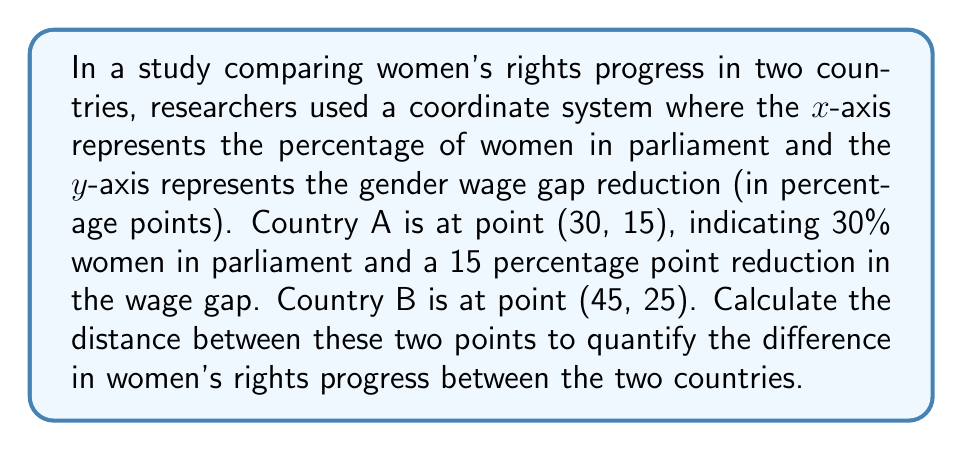Could you help me with this problem? To solve this problem, we'll use the distance formula between two points in a 2D plane. The distance formula is derived from the Pythagorean theorem:

$$d = \sqrt{(x_2 - x_1)^2 + (y_2 - y_1)^2}$$

Where $(x_1, y_1)$ represents the coordinates of the first point and $(x_2, y_2)$ represents the coordinates of the second point.

Given:
- Country A: $(x_1, y_1) = (30, 15)$
- Country B: $(x_2, y_2) = (45, 25)$

Let's substitute these values into the formula:

$$\begin{align}
d &= \sqrt{(x_2 - x_1)^2 + (y_2 - y_1)^2} \\
&= \sqrt{(45 - 30)^2 + (25 - 15)^2} \\
&= \sqrt{15^2 + 10^2} \\
&= \sqrt{225 + 100} \\
&= \sqrt{325} \\
&\approx 18.03
\end{align}$$

The result is approximately 18.03 units. In the context of our coordinate system, this represents a composite measure of the difference in women's rights progress between the two countries, taking into account both parliamentary representation and wage gap reduction.

[asy]
import geometry;

size(200);
defaultpen(fontsize(10pt));

real xmax = 50;
real ymax = 30;

draw((0,0)--(xmax,0),arrow=Arrow(TeXHead));
draw((0,0)--(0,ymax),arrow=Arrow(TeXHead));

label("Women in parliament (%)", (xmax,0), E);
label("Wage gap reduction (pp)", (0,ymax), N);

dot((30,15));
dot((45,25));

label("A (30, 15)", (30,15), SW);
label("B (45, 25)", (45,25), NE);

draw((30,15)--(45,25), dashed);
[/asy]
Answer: The distance between the two points representing women's rights progress in Country A and Country B is approximately 18.03 units. 